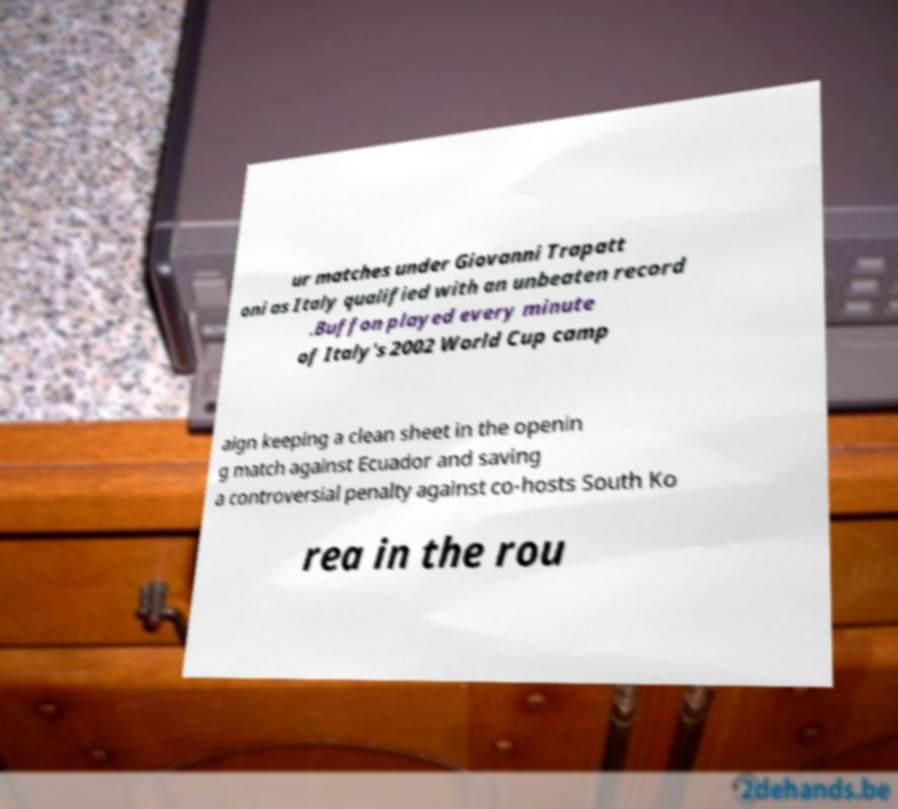There's text embedded in this image that I need extracted. Can you transcribe it verbatim? ur matches under Giovanni Trapatt oni as Italy qualified with an unbeaten record .Buffon played every minute of Italy's 2002 World Cup camp aign keeping a clean sheet in the openin g match against Ecuador and saving a controversial penalty against co-hosts South Ko rea in the rou 